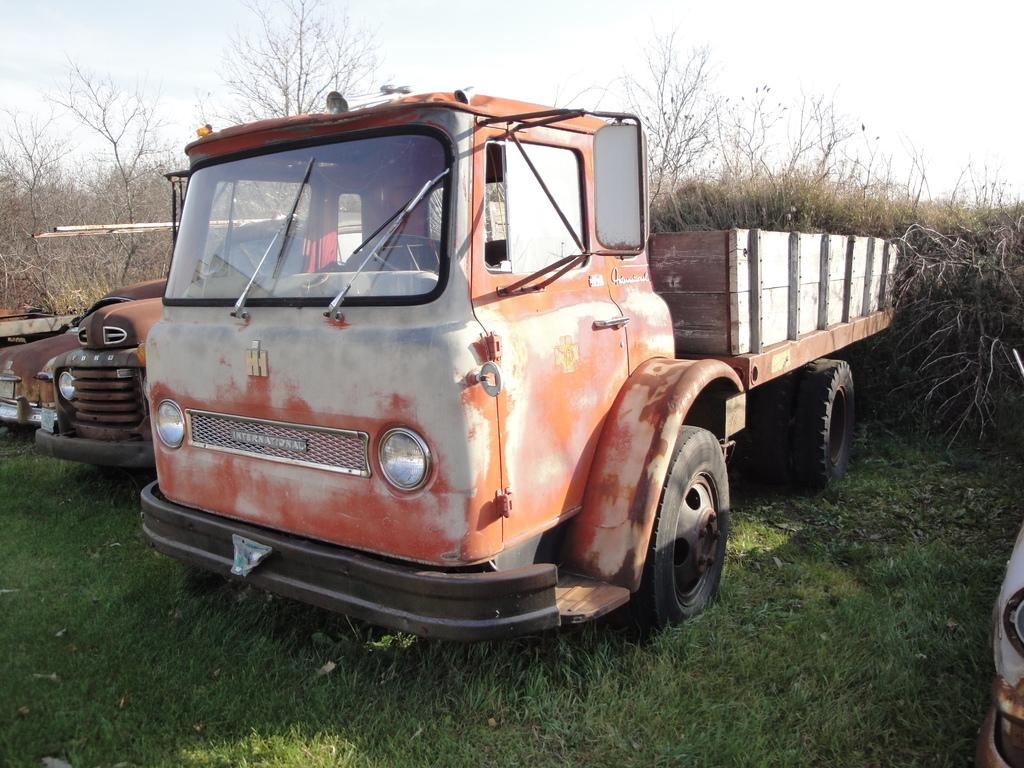What type of objects are on the ground in the image? There are vehicles on the ground in the image. What type of vegetation is visible in the image? There is grass visible in the image. What else can be seen in the image besides the vehicles and grass? There are trees in the image. What is visible in the background of the image? The sky is visible in the background of the image. What type of popcorn is being used to fuel the vehicles in the image? There is no popcorn present in the image, and vehicles are not fueled by popcorn. What is the condition of the throat of the person driving the vehicle in the image? There is no person driving a vehicle in the image, and we cannot see the throat of any person in the image. 